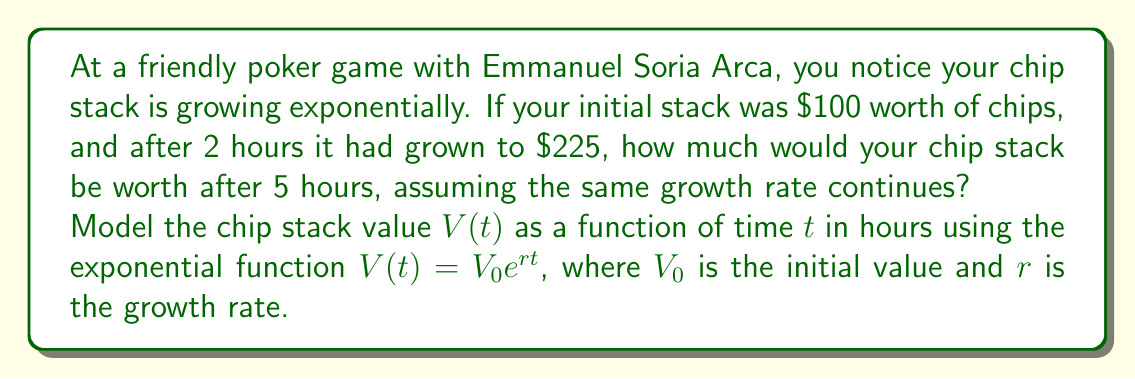Solve this math problem. Let's solve this step-by-step:

1) We're using the exponential growth model: $V(t) = V_0e^{rt}$

2) We know:
   - $V_0 = 100$ (initial value)
   - $V(2) = 225$ (value after 2 hours)
   - We need to find $V(5)$

3) First, let's find the growth rate $r$:
   
   $225 = 100e^{2r}$

4) Divide both sides by 100:

   $2.25 = e^{2r}$

5) Take the natural log of both sides:

   $\ln(2.25) = 2r$

6) Solve for $r$:

   $r = \frac{\ln(2.25)}{2} \approx 0.4055$

7) Now that we have $r$, we can find $V(5)$:

   $V(5) = 100e^{0.4055 * 5}$

8) Calculate:

   $V(5) = 100e^{2.0275} \approx 759.47$
Answer: After 5 hours, your chip stack would be worth approximately $759.47. 